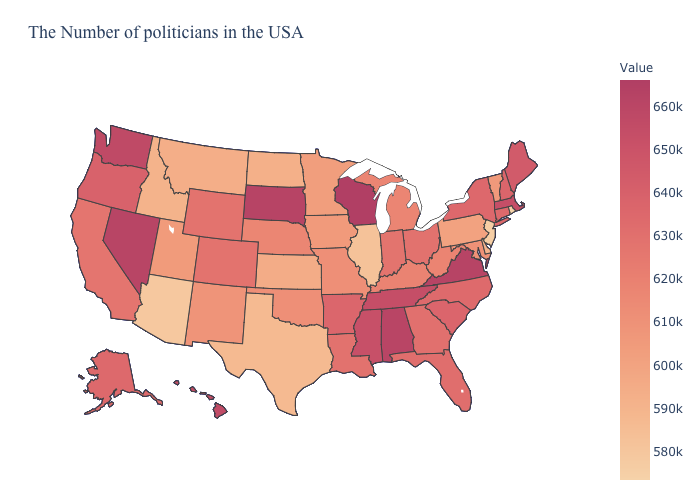Which states have the lowest value in the USA?
Give a very brief answer. Rhode Island. Does Colorado have the highest value in the West?
Be succinct. No. Which states have the highest value in the USA?
Quick response, please. Wisconsin. 